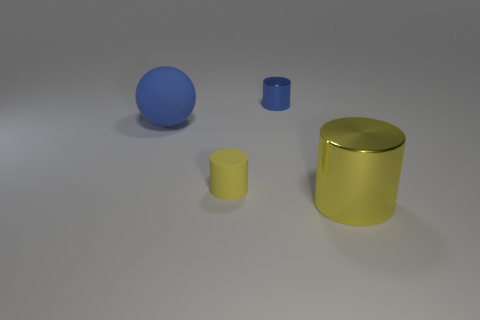What size is the cylinder behind the big sphere?
Offer a very short reply. Small. Is the number of big matte things in front of the big matte sphere the same as the number of tiny rubber objects behind the yellow rubber object?
Provide a short and direct response. Yes. The cylinder that is behind the big object to the left of the yellow object that is behind the big yellow metallic object is what color?
Keep it short and to the point. Blue. How many big objects are both to the left of the big metal object and to the right of the blue ball?
Offer a very short reply. 0. Do the metallic cylinder that is in front of the yellow matte thing and the tiny object that is on the left side of the small blue object have the same color?
Provide a short and direct response. Yes. Is there any other thing that is made of the same material as the small blue object?
Your answer should be very brief. Yes. There is another blue object that is the same shape as the small rubber object; what is its size?
Provide a succinct answer. Small. Are there any tiny things on the right side of the small yellow matte cylinder?
Provide a short and direct response. Yes. Are there the same number of things that are on the right side of the small metallic thing and big metallic objects?
Your answer should be compact. Yes. Is there a small blue metal cylinder that is in front of the blue thing that is behind the large object that is left of the big yellow cylinder?
Offer a terse response. No. 